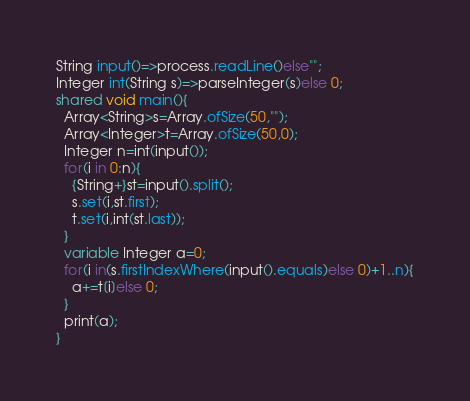Convert code to text. <code><loc_0><loc_0><loc_500><loc_500><_Ceylon_>String input()=>process.readLine()else""; 
Integer int(String s)=>parseInteger(s)else 0;
shared void main(){
  Array<String>s=Array.ofSize(50,"");
  Array<Integer>t=Array.ofSize(50,0);
  Integer n=int(input());
  for(i in 0:n){
    {String+}st=input().split();
    s.set(i,st.first);
    t.set(i,int(st.last));
  }
  variable Integer a=0;
  for(i in(s.firstIndexWhere(input().equals)else 0)+1..n){
    a+=t[i]else 0;
  }
  print(a);
}</code> 